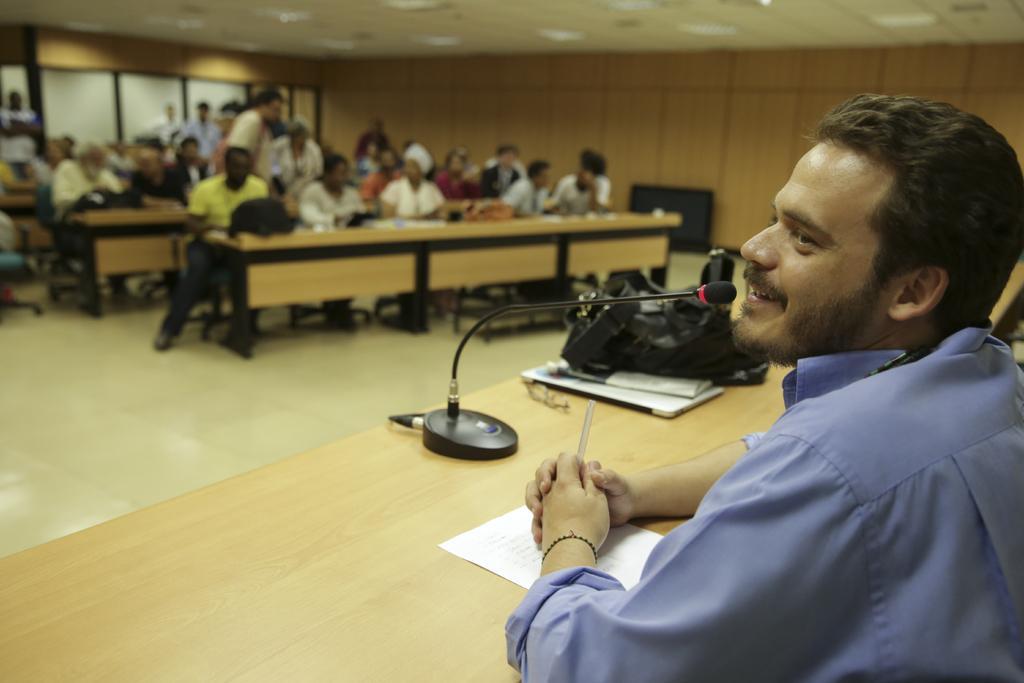In one or two sentences, can you explain what this image depicts? On the right side of the image we can see one person sitting and holding some object and he is smiling, which we can see on his face. In front of him, there is a table. On the table, we can see one paper, microphone, one bag, glasses, books and a few other objects. In the background there is a wall, roof, white color objects, one monitor, bags, tables, benches, papers, few people are sitting on the benches, few people are standing and a few other objects. 